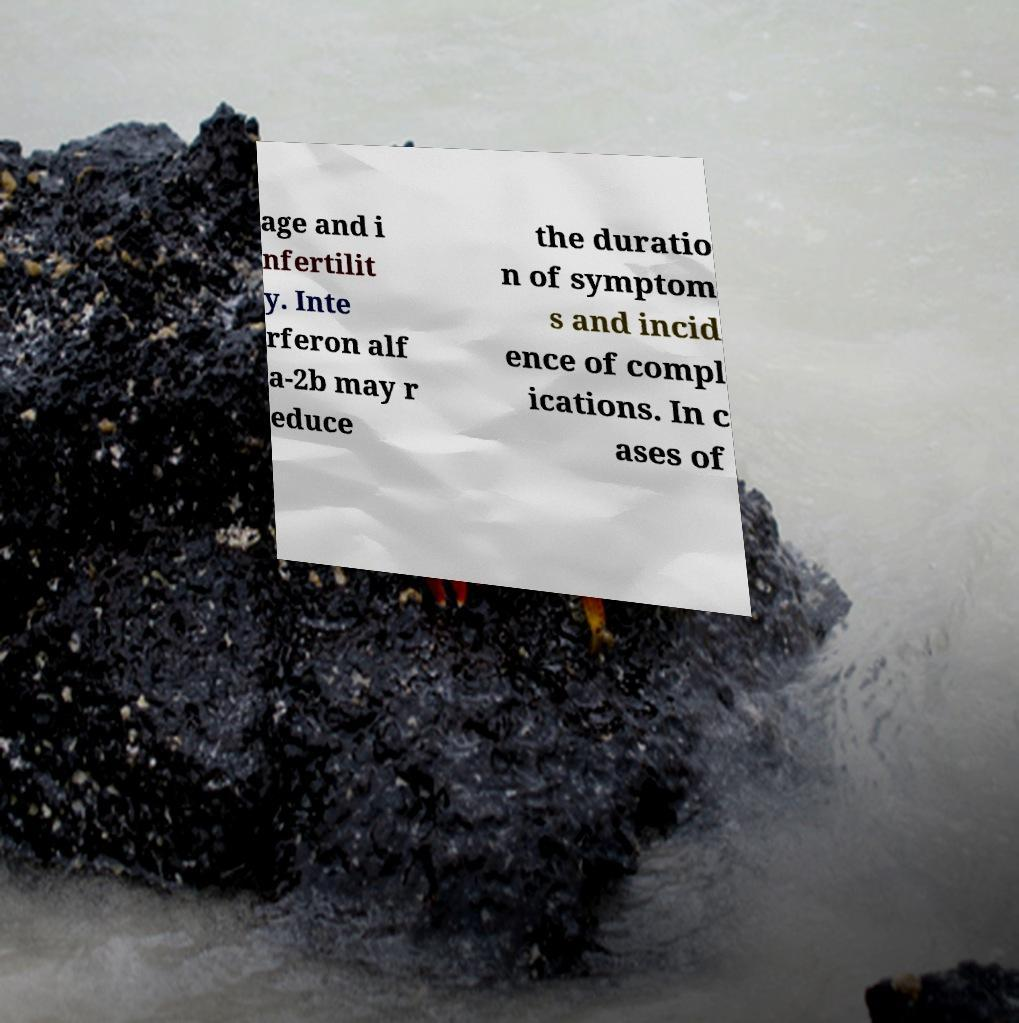Could you extract and type out the text from this image? age and i nfertilit y. Inte rferon alf a-2b may r educe the duratio n of symptom s and incid ence of compl ications. In c ases of 